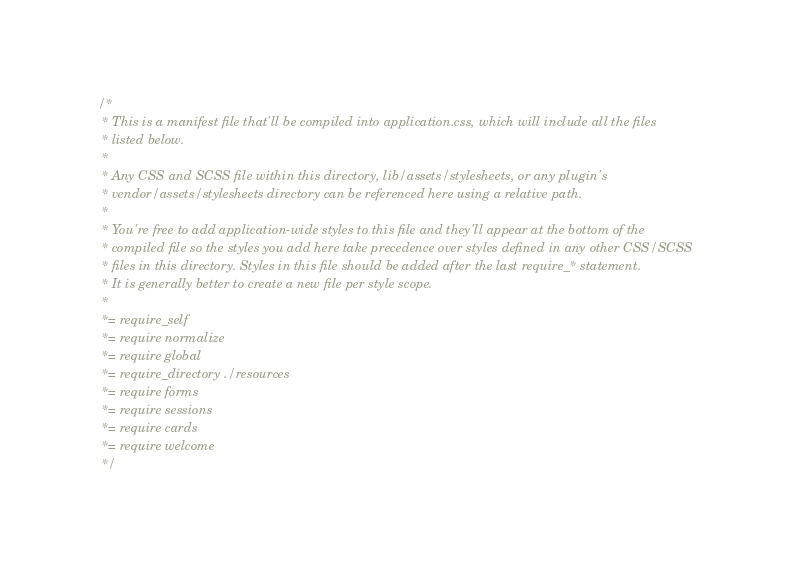Convert code to text. <code><loc_0><loc_0><loc_500><loc_500><_CSS_>/*
 * This is a manifest file that'll be compiled into application.css, which will include all the files
 * listed below.
 *
 * Any CSS and SCSS file within this directory, lib/assets/stylesheets, or any plugin's
 * vendor/assets/stylesheets directory can be referenced here using a relative path.
 *
 * You're free to add application-wide styles to this file and they'll appear at the bottom of the
 * compiled file so the styles you add here take precedence over styles defined in any other CSS/SCSS
 * files in this directory. Styles in this file should be added after the last require_* statement.
 * It is generally better to create a new file per style scope.
 *
 *= require_self
 *= require normalize
 *= require global
 *= require_directory ./resources
 *= require forms
 *= require sessions
 *= require cards
 *= require welcome
 */
</code> 